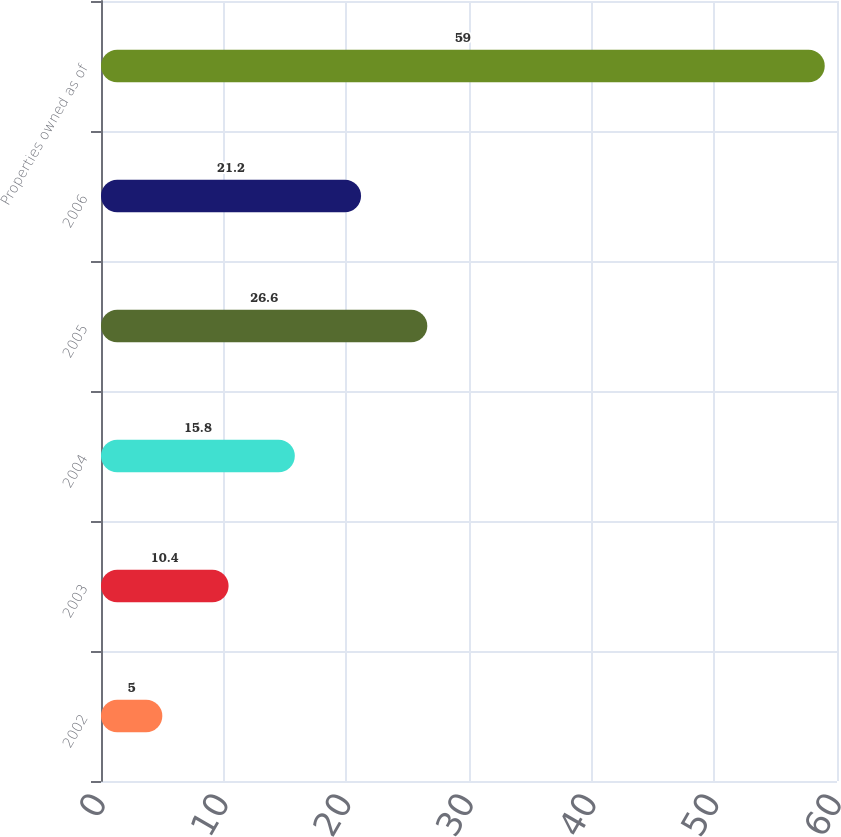<chart> <loc_0><loc_0><loc_500><loc_500><bar_chart><fcel>2002<fcel>2003<fcel>2004<fcel>2005<fcel>2006<fcel>Properties owned as of<nl><fcel>5<fcel>10.4<fcel>15.8<fcel>26.6<fcel>21.2<fcel>59<nl></chart> 